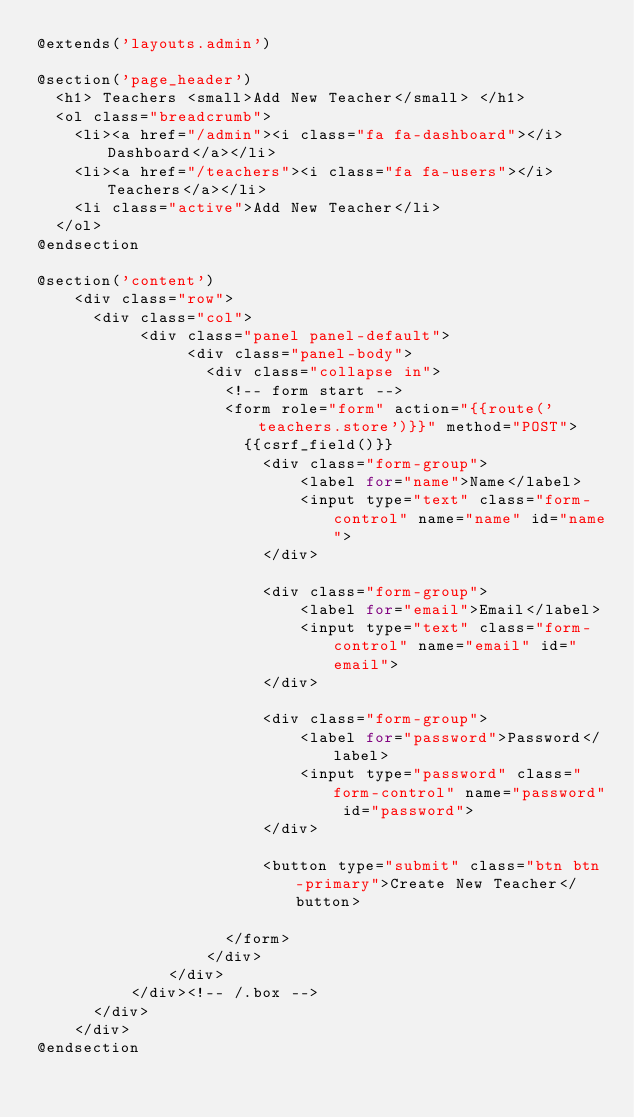Convert code to text. <code><loc_0><loc_0><loc_500><loc_500><_PHP_>@extends('layouts.admin')

@section('page_header')
  <h1> Teachers <small>Add New Teacher</small> </h1>
  <ol class="breadcrumb">
    <li><a href="/admin"><i class="fa fa-dashboard"></i> Dashboard</a></li>
    <li><a href="/teachers"><i class="fa fa-users"></i> Teachers</a></li>
    <li class="active">Add New Teacher</li>
  </ol>
@endsection

@section('content')
  	<div class="row">
      <div class="col">
           <div class="panel panel-default">
                <div class="panel-body"> 
                  <div class="collapse in">
                    <!-- form start -->
                    <form role="form" action="{{route('teachers.store')}}" method="POST">
                      {{csrf_field()}}      
                        <div class="form-group">
                            <label for="name">Name</label>
                            <input type="text" class="form-control" name="name" id="name">
                        </div>

                        <div class="form-group">
                            <label for="email">Email</label>
                            <input type="text" class="form-control" name="email" id="email">
                        </div>

                        <div class="form-group">
                            <label for="password">Password</label>
                            <input type="password" class="form-control" name="password" id="password">
                        </div>

                        <button type="submit" class="btn btn-primary">Create New Teacher</button>
                           
                    </form>   
                  </div>
              </div>
          </div><!-- /.box -->
      </div>
    </div>
@endsection</code> 